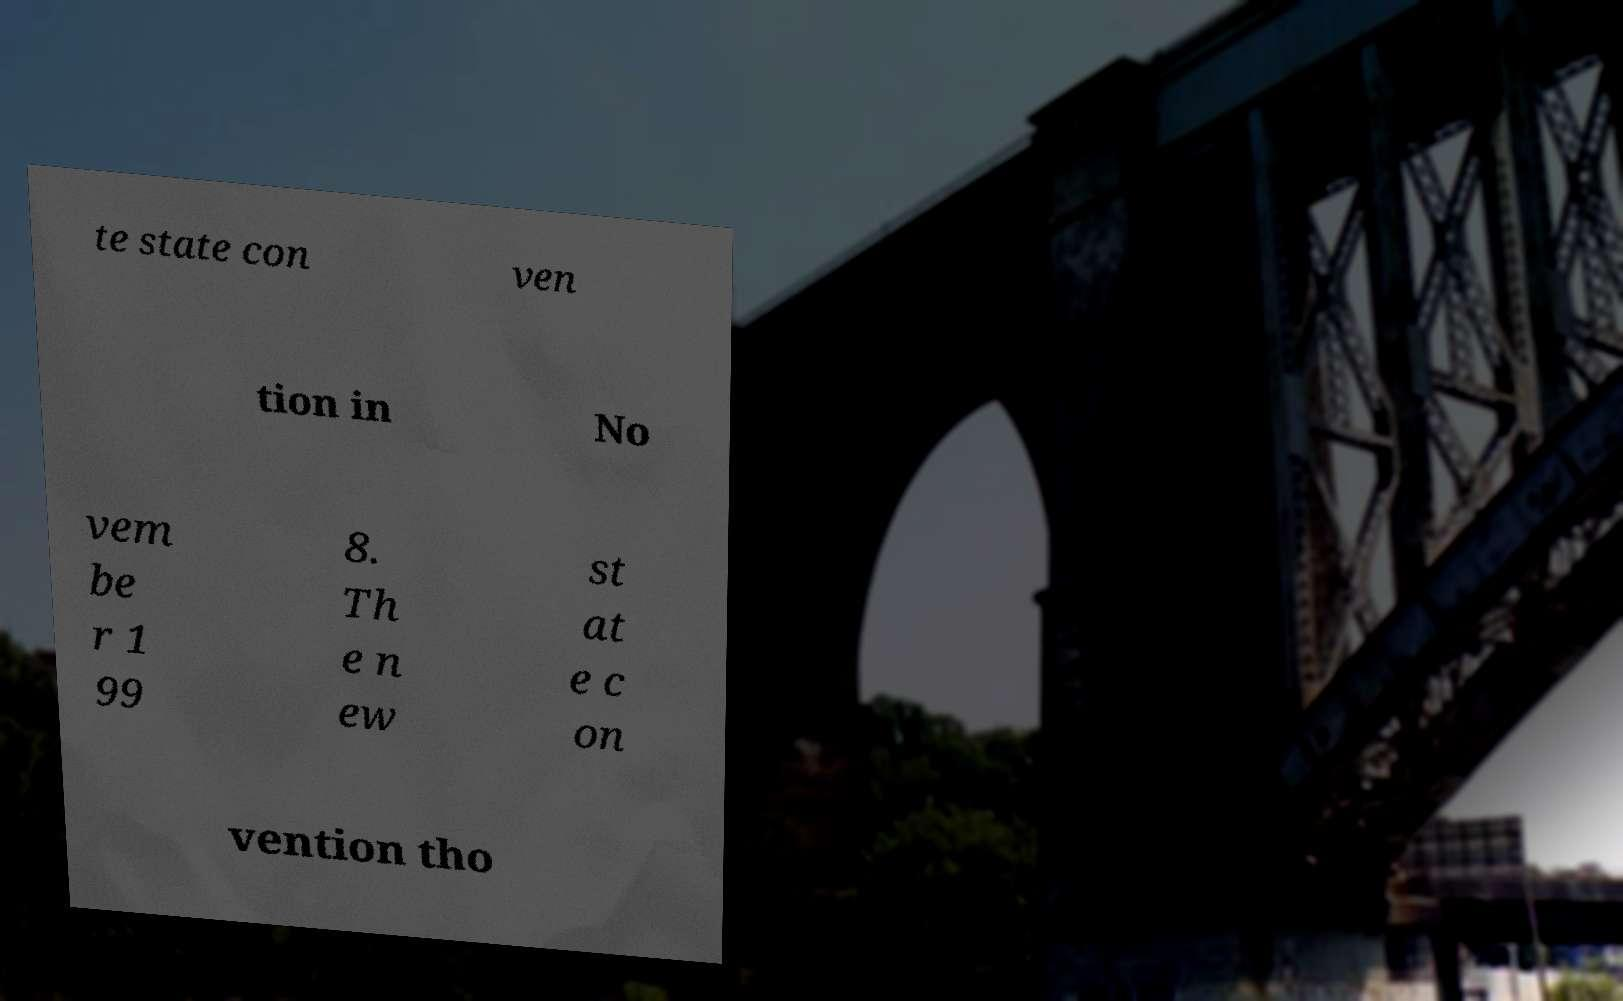What messages or text are displayed in this image? I need them in a readable, typed format. te state con ven tion in No vem be r 1 99 8. Th e n ew st at e c on vention tho 